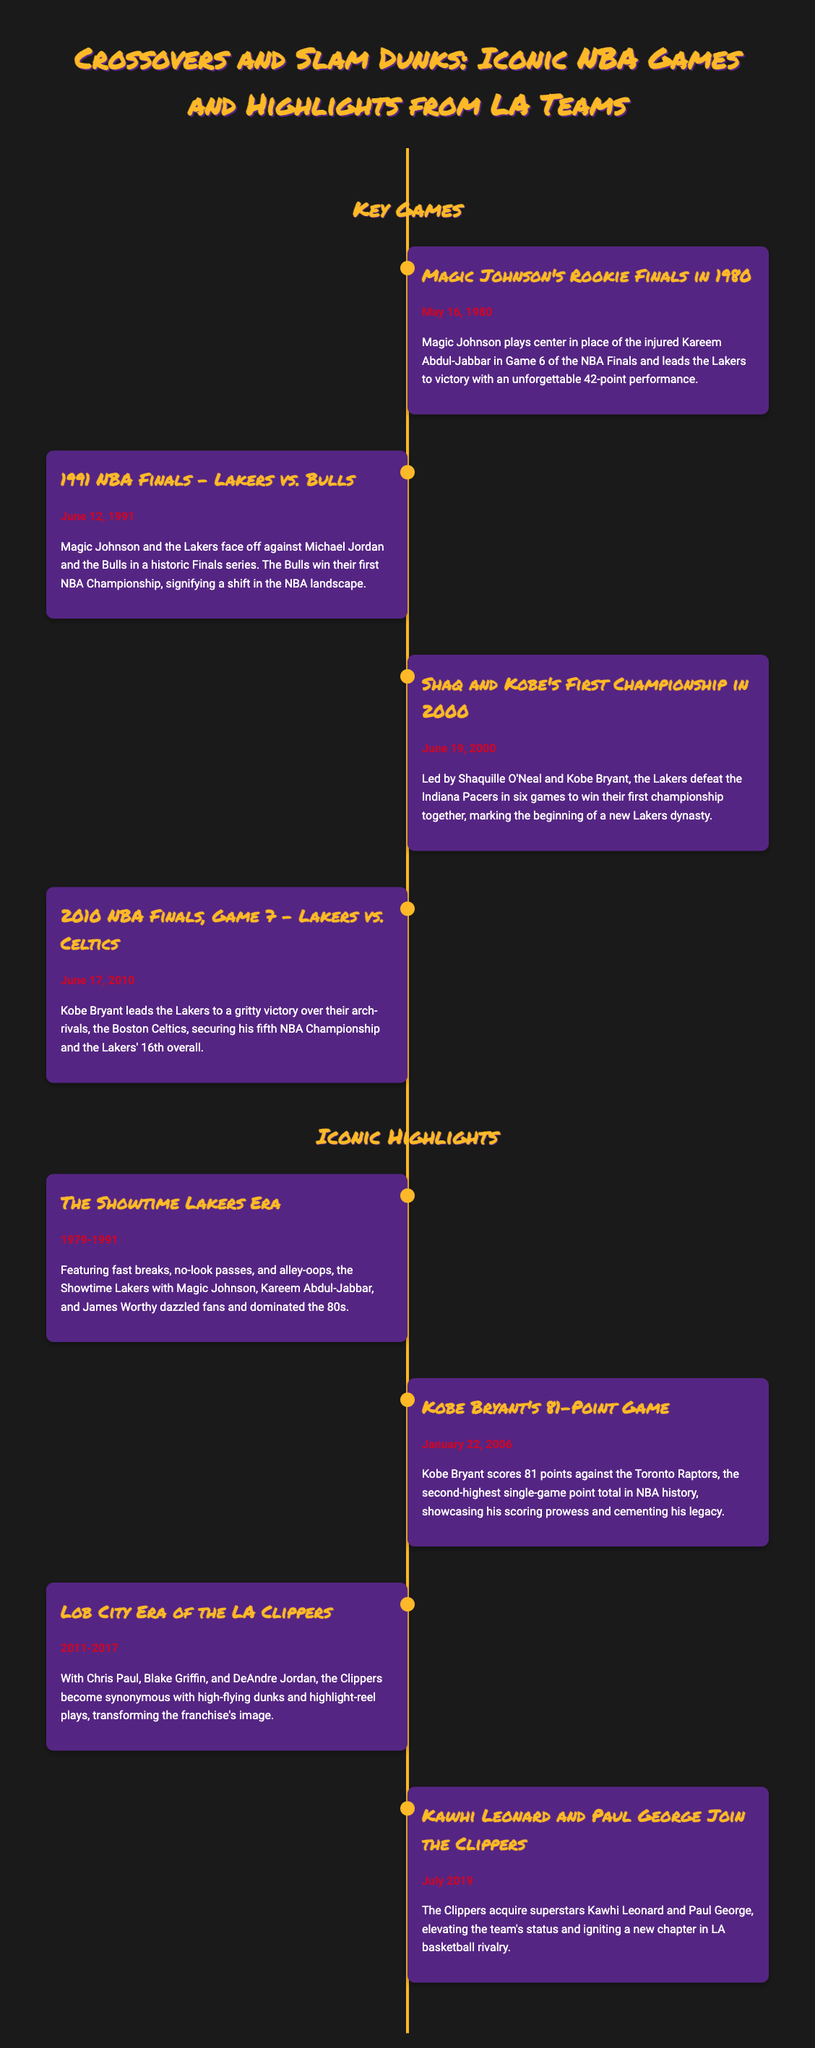What date did Magic Johnson play center in the NBA Finals? The document states that Magic Johnson played center in Game 6 of the NBA Finals on May 16, 1980.
Answer: May 16, 1980 Who did the Lakers defeat for their first championship with Shaq and Kobe? The document mentions that the Lakers defeated the Indiana Pacers to win their first championship together in 2000.
Answer: Indiana Pacers What significant performance did Kobe Bryant achieve on January 22, 2006? The timeline highlights that Kobe Bryant scored 81 points against the Toronto Raptors, a record-setting performance.
Answer: 81 points Which era is associated with fast breaks and alley-oops for the Lakers? The timeline refers to the Showtime Lakers Era as being known for fast breaks and alley-oops.
Answer: Showtime Lakers Era In what year did Kawhi Leonard and Paul George join the Clippers? The document states that Kawhi Leonard and Paul George joined the Clippers in July 2019.
Answer: July 2019 What was the outcome of the 2010 NBA Finals Game 7? The document indicates that the Lakers won the 2010 NBA Finals Game 7 against the Boston Celtics.
Answer: Lakers won What term describes the time when Chris Paul and Blake Griffin played for the Clippers? The document describes the time from 2011 to 2017 as the Lob City Era for the Clippers.
Answer: Lob City Era How many championships has Kobe Bryant won according to the document? The timeline mentions that Kobe Bryant secured his fifth NBA Championship in the 2010 Finals.
Answer: Five 